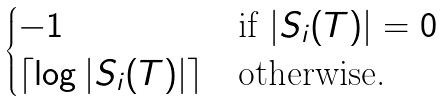<formula> <loc_0><loc_0><loc_500><loc_500>\begin{cases} - 1 & \text {if } | S _ { i } ( T ) | = 0 \\ \lceil \log | S _ { i } ( T ) | \rceil & \text {otherwise.} \end{cases}</formula> 